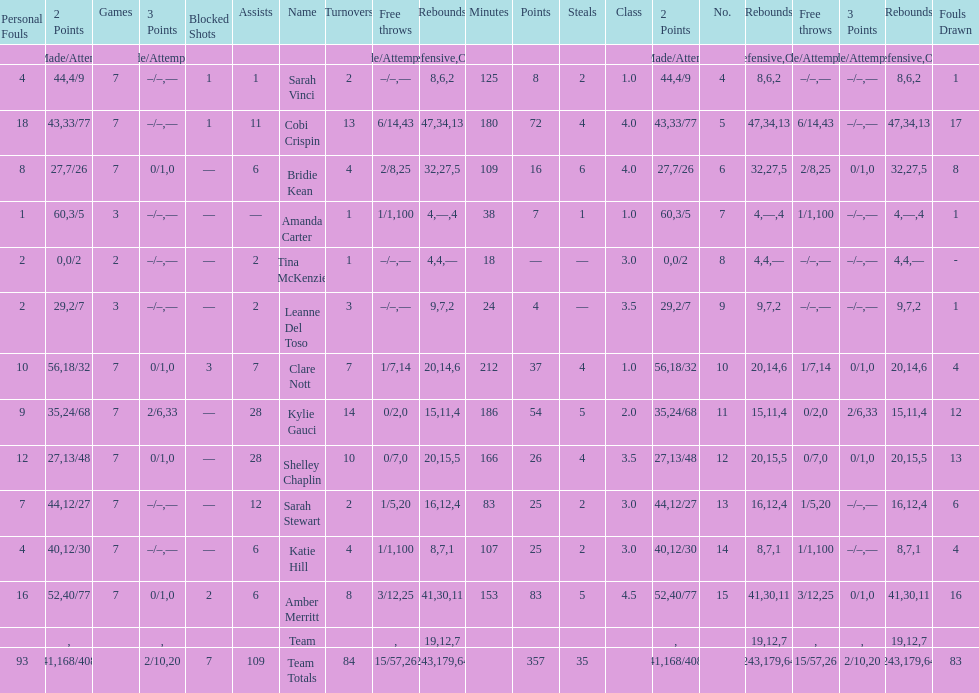Number of 3 points attempted 10. 